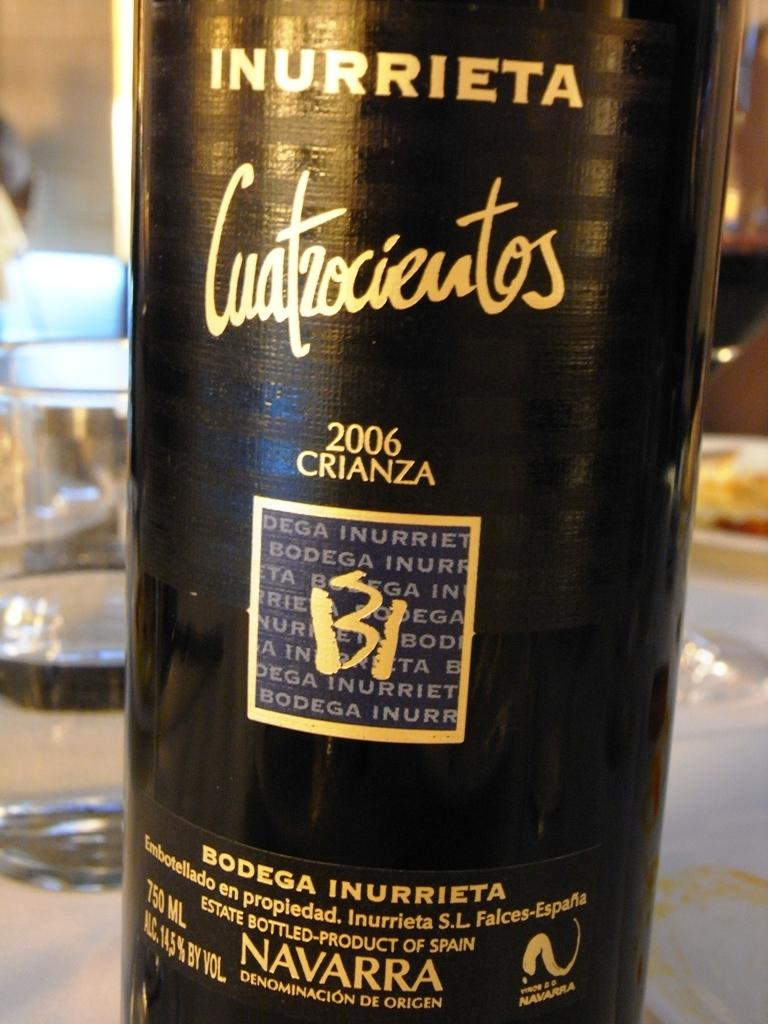Provide a one-sentence caption for the provided image. A bottle of Inurrieta on a table with glasses and food. 